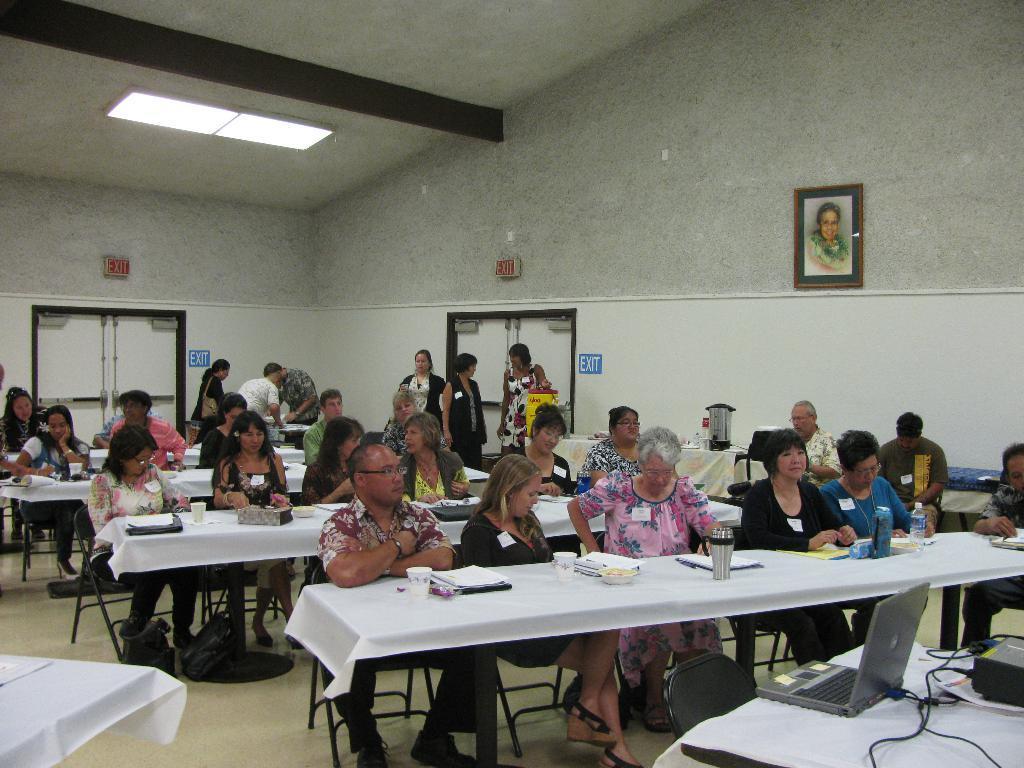Describe this image in one or two sentences. In the image we can see group of people were sitting on the chair in front of them there is a table,on table they were few objects like books,glasses and pen etc. And back of these people the three more ladies in the center they were standing and discussing something. Back of them there is a wall on wall there is a photo frame,and in the right corner we can see a laptop. 